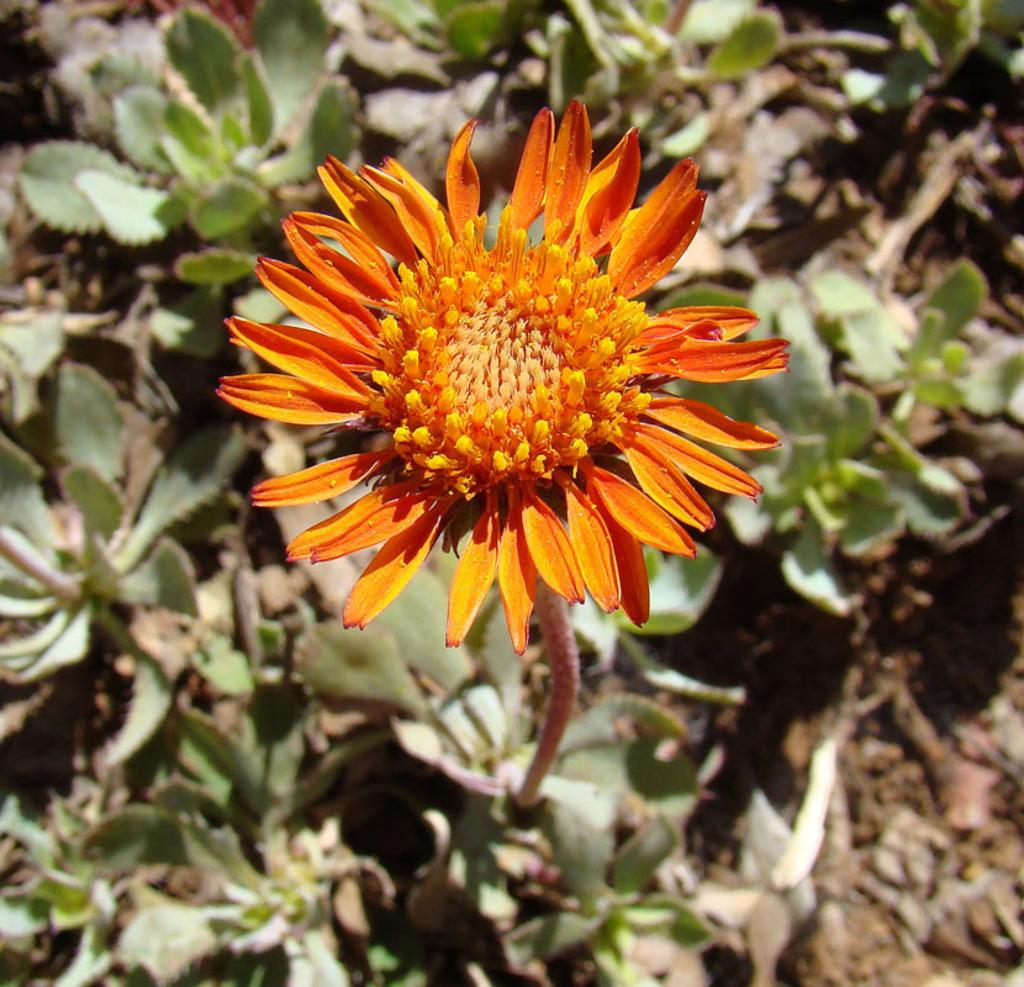What is the main subject of the image? There is a flower in the image. What can be seen in the background of the image? There are planets visible in the background of the image. How many pets are sitting on the carriage in the image? There is no carriage or pets present in the image. What type of sand can be seen on the beach in the image? There is no beach or sand present in the image. 